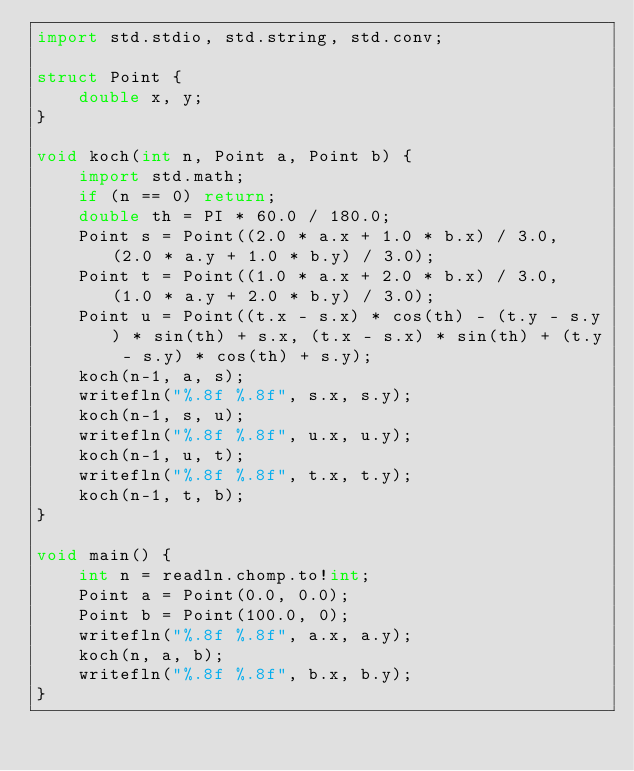Convert code to text. <code><loc_0><loc_0><loc_500><loc_500><_D_>import std.stdio, std.string, std.conv;

struct Point {
    double x, y;
}

void koch(int n, Point a, Point b) {
    import std.math;
    if (n == 0) return;
    double th = PI * 60.0 / 180.0;
    Point s = Point((2.0 * a.x + 1.0 * b.x) / 3.0, (2.0 * a.y + 1.0 * b.y) / 3.0);
    Point t = Point((1.0 * a.x + 2.0 * b.x) / 3.0, (1.0 * a.y + 2.0 * b.y) / 3.0);
    Point u = Point((t.x - s.x) * cos(th) - (t.y - s.y) * sin(th) + s.x, (t.x - s.x) * sin(th) + (t.y - s.y) * cos(th) + s.y);
    koch(n-1, a, s);
    writefln("%.8f %.8f", s.x, s.y);
    koch(n-1, s, u);
    writefln("%.8f %.8f", u.x, u.y);
    koch(n-1, u, t);
    writefln("%.8f %.8f", t.x, t.y);
    koch(n-1, t, b);
}

void main() {
    int n = readln.chomp.to!int;
    Point a = Point(0.0, 0.0);
    Point b = Point(100.0, 0);
    writefln("%.8f %.8f", a.x, a.y);
    koch(n, a, b);
    writefln("%.8f %.8f", b.x, b.y);
}
</code> 